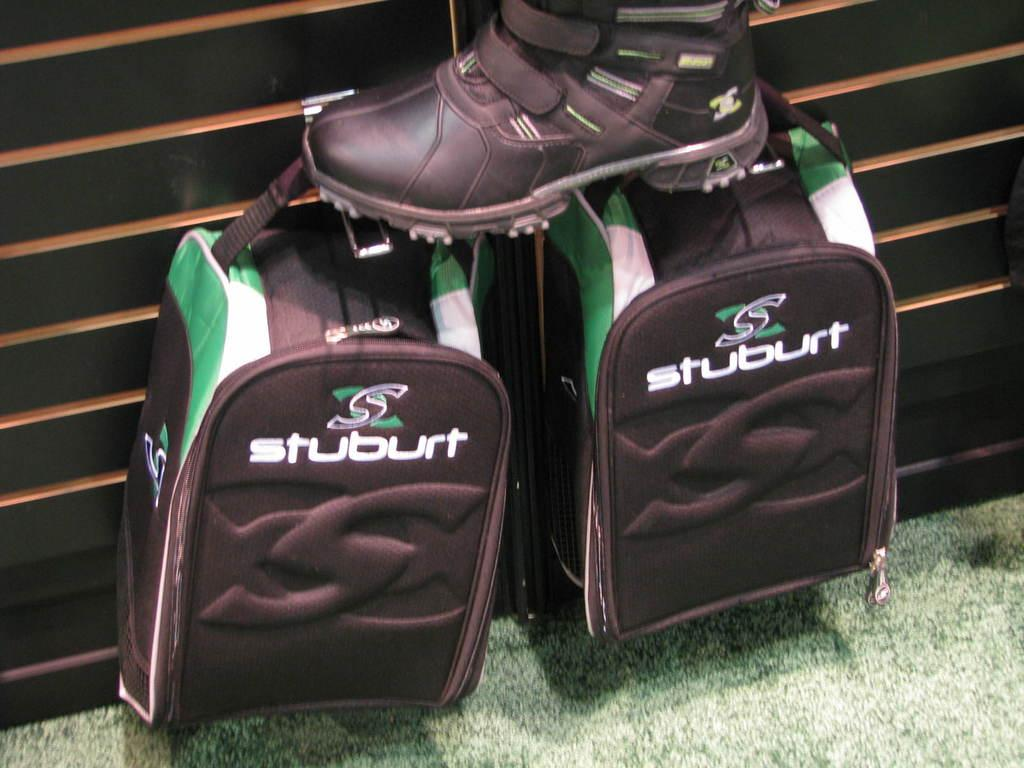How many bags can be seen in the image? There are two bags in the image. What is placed over one of the bags? There is a shoe placed over one of the bags. What language is spoken by the oatmeal in the image? There is no oatmeal present in the image, so it cannot speak any language. 